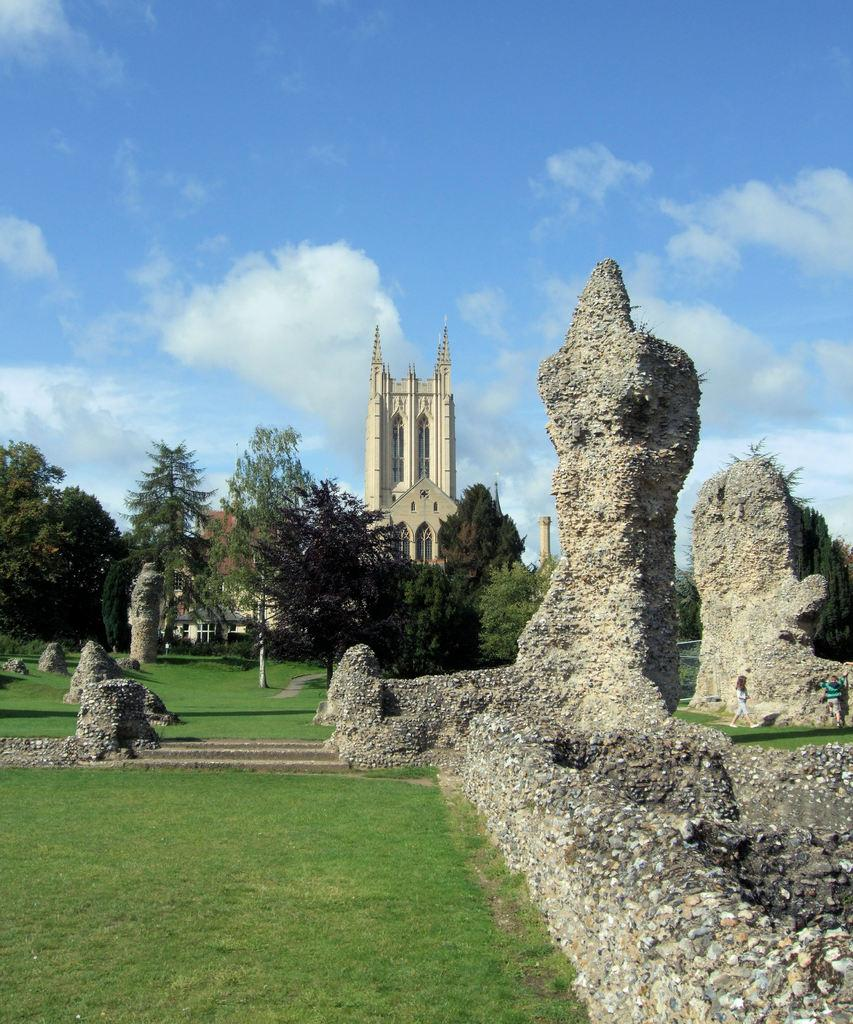What type of structure is visible in the image? There is a building with windows in the image. Can you describe the possible purpose of the building? The building may be a church. What natural elements can be seen in the image? There are trees, rocks, and grass in the image. How many people are present in the image? Two people are standing in the image. What letters are being carried by the moon in the image? There is no moon present in the image, and therefore no letters can be carried by it. 